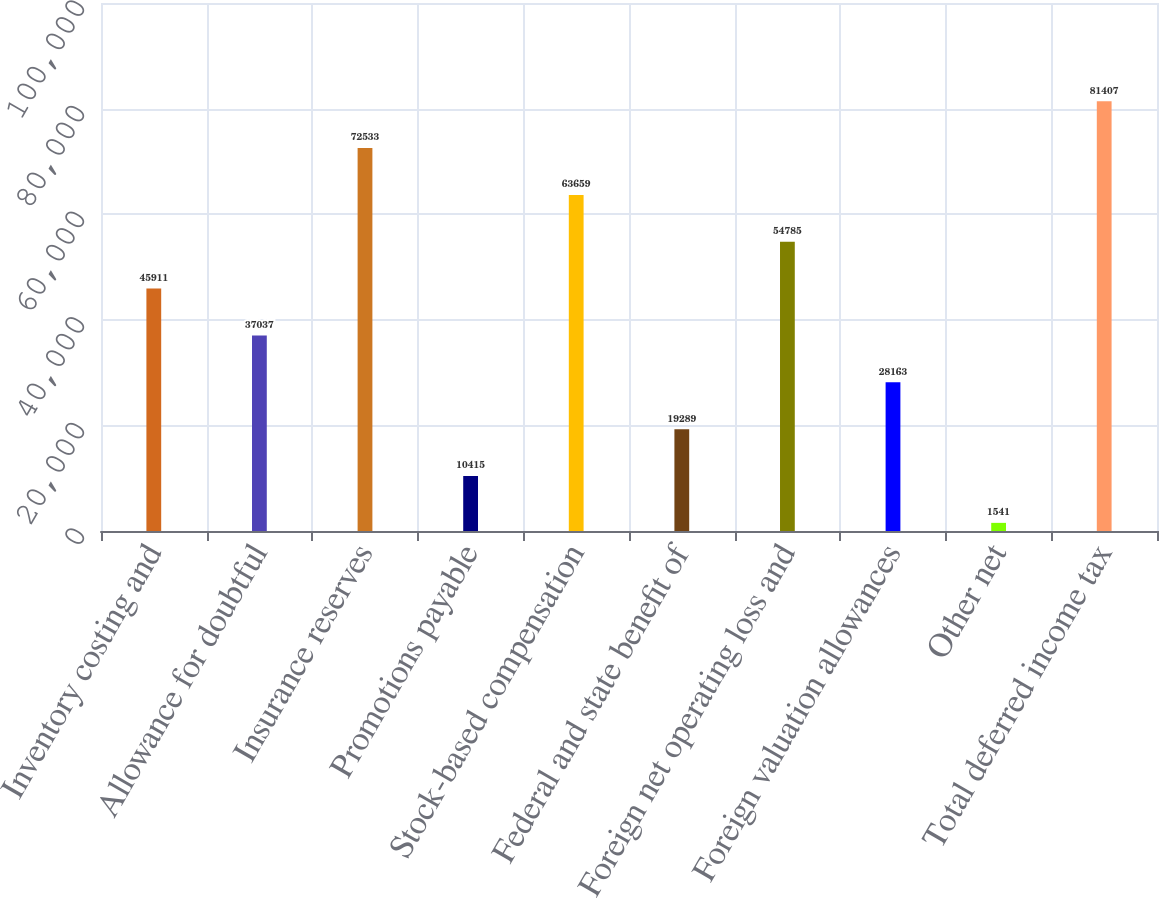<chart> <loc_0><loc_0><loc_500><loc_500><bar_chart><fcel>Inventory costing and<fcel>Allowance for doubtful<fcel>Insurance reserves<fcel>Promotions payable<fcel>Stock-based compensation<fcel>Federal and state benefit of<fcel>Foreign net operating loss and<fcel>Foreign valuation allowances<fcel>Other net<fcel>Total deferred income tax<nl><fcel>45911<fcel>37037<fcel>72533<fcel>10415<fcel>63659<fcel>19289<fcel>54785<fcel>28163<fcel>1541<fcel>81407<nl></chart> 